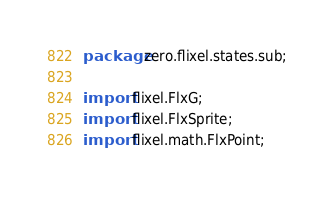<code> <loc_0><loc_0><loc_500><loc_500><_Haxe_>package zero.flixel.states.sub;

import flixel.FlxG;
import flixel.FlxSprite;
import flixel.math.FlxPoint;</code> 